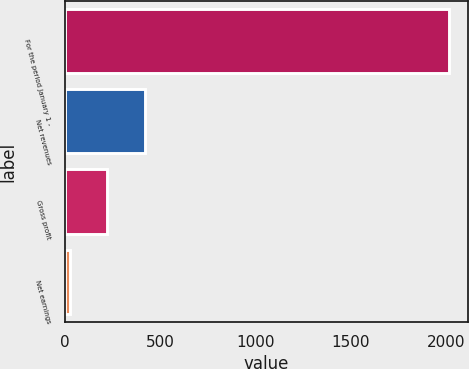Convert chart to OTSL. <chart><loc_0><loc_0><loc_500><loc_500><bar_chart><fcel>For the period January 1 -<fcel>Net revenues<fcel>Gross profit<fcel>Net earnings<nl><fcel>2017<fcel>423.96<fcel>224.83<fcel>25.7<nl></chart> 